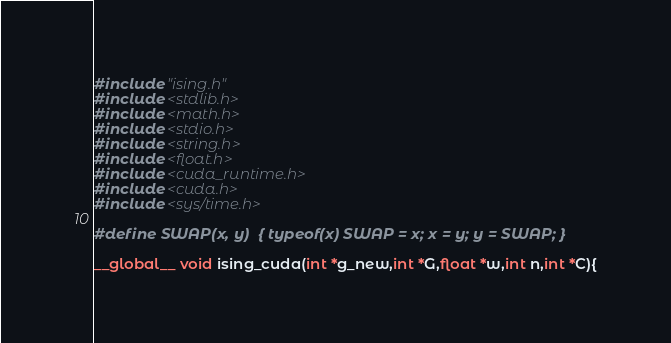<code> <loc_0><loc_0><loc_500><loc_500><_Cuda_>#include "ising.h"
#include <stdlib.h>
#include <math.h>
#include <stdio.h>
#include <string.h>
#include <float.h>
#include <cuda_runtime.h>
#include <cuda.h>
#include <sys/time.h>

#define SWAP(x, y)  { typeof(x) SWAP = x; x = y; y = SWAP; } 

__global__ void ising_cuda(int *g_new,int *G,float *w,int n,int *C){
</code> 